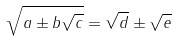Convert formula to latex. <formula><loc_0><loc_0><loc_500><loc_500>\sqrt { a \pm b \sqrt { c } } = \sqrt { d } \pm \sqrt { e }</formula> 